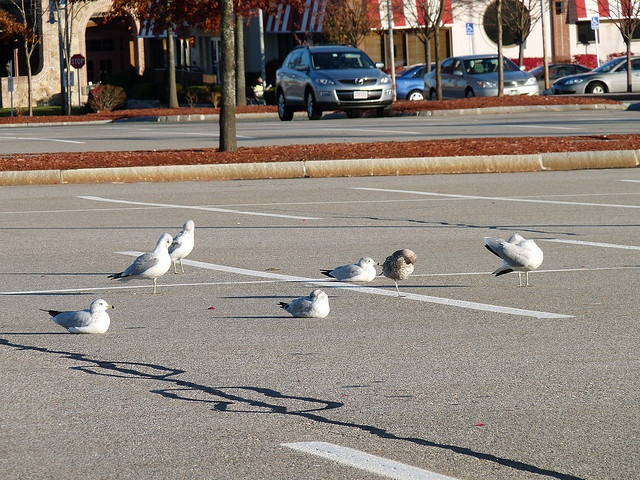Describe the objects in this image and their specific colors. I can see car in black, blue, gray, and navy tones, car in black, gray, navy, and blue tones, car in black, darkgray, gray, and lightgray tones, bird in black, white, darkgray, and gray tones, and bird in black, white, gray, darkgray, and blue tones in this image. 